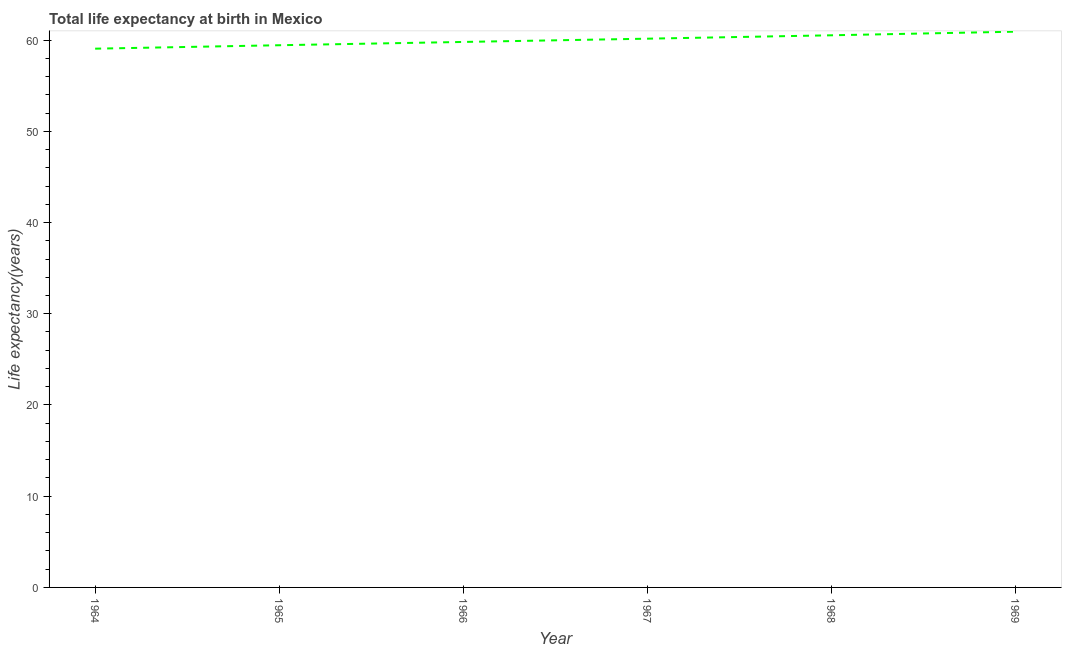What is the life expectancy at birth in 1964?
Offer a very short reply. 59.06. Across all years, what is the maximum life expectancy at birth?
Your answer should be very brief. 60.92. Across all years, what is the minimum life expectancy at birth?
Your answer should be compact. 59.06. In which year was the life expectancy at birth maximum?
Your response must be concise. 1969. In which year was the life expectancy at birth minimum?
Provide a short and direct response. 1964. What is the sum of the life expectancy at birth?
Provide a short and direct response. 359.88. What is the difference between the life expectancy at birth in 1965 and 1966?
Your answer should be compact. -0.36. What is the average life expectancy at birth per year?
Keep it short and to the point. 59.98. What is the median life expectancy at birth?
Ensure brevity in your answer.  59.97. What is the ratio of the life expectancy at birth in 1966 to that in 1967?
Your answer should be very brief. 0.99. Is the life expectancy at birth in 1967 less than that in 1969?
Offer a very short reply. Yes. Is the difference between the life expectancy at birth in 1964 and 1968 greater than the difference between any two years?
Provide a short and direct response. No. What is the difference between the highest and the second highest life expectancy at birth?
Make the answer very short. 0.4. Is the sum of the life expectancy at birth in 1965 and 1966 greater than the maximum life expectancy at birth across all years?
Your response must be concise. Yes. What is the difference between the highest and the lowest life expectancy at birth?
Keep it short and to the point. 1.86. In how many years, is the life expectancy at birth greater than the average life expectancy at birth taken over all years?
Give a very brief answer. 3. Are the values on the major ticks of Y-axis written in scientific E-notation?
Offer a terse response. No. Does the graph contain grids?
Offer a very short reply. No. What is the title of the graph?
Give a very brief answer. Total life expectancy at birth in Mexico. What is the label or title of the Y-axis?
Ensure brevity in your answer.  Life expectancy(years). What is the Life expectancy(years) in 1964?
Make the answer very short. 59.06. What is the Life expectancy(years) of 1965?
Ensure brevity in your answer.  59.43. What is the Life expectancy(years) in 1966?
Give a very brief answer. 59.79. What is the Life expectancy(years) of 1967?
Make the answer very short. 60.15. What is the Life expectancy(years) of 1968?
Give a very brief answer. 60.52. What is the Life expectancy(years) in 1969?
Your answer should be very brief. 60.92. What is the difference between the Life expectancy(years) in 1964 and 1965?
Your answer should be very brief. -0.38. What is the difference between the Life expectancy(years) in 1964 and 1966?
Provide a short and direct response. -0.74. What is the difference between the Life expectancy(years) in 1964 and 1967?
Provide a short and direct response. -1.1. What is the difference between the Life expectancy(years) in 1964 and 1968?
Make the answer very short. -1.47. What is the difference between the Life expectancy(years) in 1964 and 1969?
Provide a succinct answer. -1.86. What is the difference between the Life expectancy(years) in 1965 and 1966?
Provide a short and direct response. -0.36. What is the difference between the Life expectancy(years) in 1965 and 1967?
Provide a short and direct response. -0.72. What is the difference between the Life expectancy(years) in 1965 and 1968?
Offer a terse response. -1.09. What is the difference between the Life expectancy(years) in 1965 and 1969?
Provide a short and direct response. -1.49. What is the difference between the Life expectancy(years) in 1966 and 1967?
Give a very brief answer. -0.36. What is the difference between the Life expectancy(years) in 1966 and 1968?
Keep it short and to the point. -0.73. What is the difference between the Life expectancy(years) in 1966 and 1969?
Offer a very short reply. -1.13. What is the difference between the Life expectancy(years) in 1967 and 1968?
Give a very brief answer. -0.37. What is the difference between the Life expectancy(years) in 1967 and 1969?
Give a very brief answer. -0.77. What is the difference between the Life expectancy(years) in 1968 and 1969?
Offer a very short reply. -0.4. What is the ratio of the Life expectancy(years) in 1964 to that in 1965?
Offer a terse response. 0.99. What is the ratio of the Life expectancy(years) in 1964 to that in 1966?
Your answer should be compact. 0.99. What is the ratio of the Life expectancy(years) in 1964 to that in 1967?
Your answer should be very brief. 0.98. What is the ratio of the Life expectancy(years) in 1964 to that in 1968?
Provide a short and direct response. 0.98. What is the ratio of the Life expectancy(years) in 1964 to that in 1969?
Ensure brevity in your answer.  0.97. What is the ratio of the Life expectancy(years) in 1965 to that in 1966?
Make the answer very short. 0.99. What is the ratio of the Life expectancy(years) in 1966 to that in 1967?
Give a very brief answer. 0.99. What is the ratio of the Life expectancy(years) in 1968 to that in 1969?
Offer a very short reply. 0.99. 